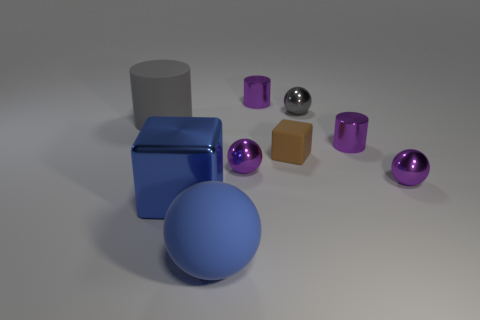Do the tiny brown block and the big cube have the same material?
Give a very brief answer. No. What number of metal objects are either blue cylinders or big blue things?
Offer a terse response. 1. There is a blue object that is behind the big blue matte ball; what shape is it?
Make the answer very short. Cube. There is a blue object that is the same material as the brown cube; what is its size?
Offer a very short reply. Large. What is the shape of the tiny metallic object that is both in front of the matte cube and right of the tiny rubber object?
Ensure brevity in your answer.  Sphere. Is the color of the rubber object that is right of the big blue rubber object the same as the shiny cube?
Keep it short and to the point. No. There is a purple object that is behind the small gray metal thing; is it the same shape as the big blue shiny thing that is to the left of the small brown rubber cube?
Provide a short and direct response. No. There is a purple shiny ball left of the small gray thing; what is its size?
Your answer should be very brief. Small. What size is the purple shiny cylinder that is right of the block that is right of the big metal object?
Keep it short and to the point. Small. Are there more small things than brown matte objects?
Offer a terse response. Yes. 